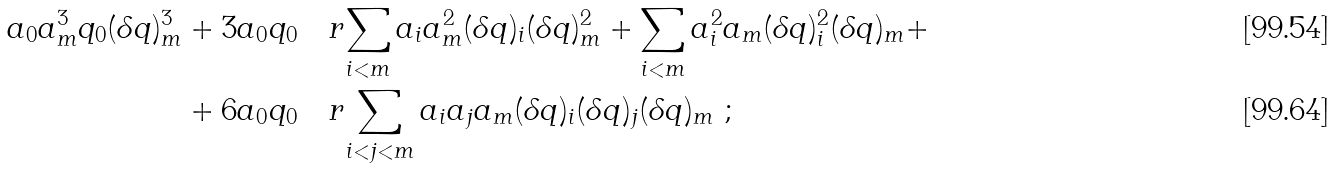<formula> <loc_0><loc_0><loc_500><loc_500>a _ { 0 } a _ { m } ^ { 3 } q _ { 0 } ( \delta q ) _ { m } ^ { 3 } & + 3 a _ { 0 } q _ { 0 } \quad r { \sum _ { i < m } a _ { i } a _ { m } ^ { 2 } ( \delta q ) _ { i } ( \delta q ) _ { m } ^ { 2 } + \sum _ { i < m } a _ { i } ^ { 2 } a _ { m } ( \delta q ) _ { i } ^ { 2 } ( \delta q ) _ { m } } + \\ & + 6 a _ { 0 } q _ { 0 } \quad r { \sum _ { i < j < m } a _ { i } a _ { j } a _ { m } ( \delta q ) _ { i } ( \delta q ) _ { j } ( \delta q ) _ { m } } \ ;</formula> 